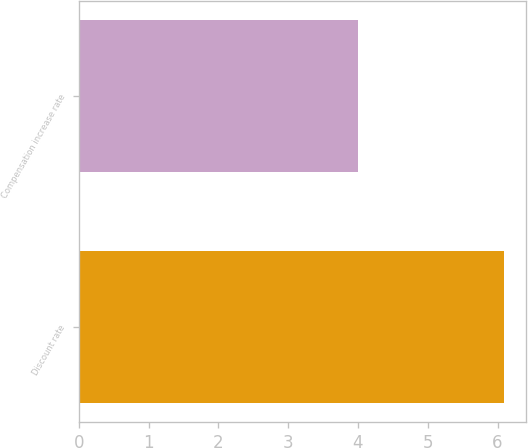Convert chart. <chart><loc_0><loc_0><loc_500><loc_500><bar_chart><fcel>Discount rate<fcel>Compensation increase rate<nl><fcel>6.1<fcel>4<nl></chart> 